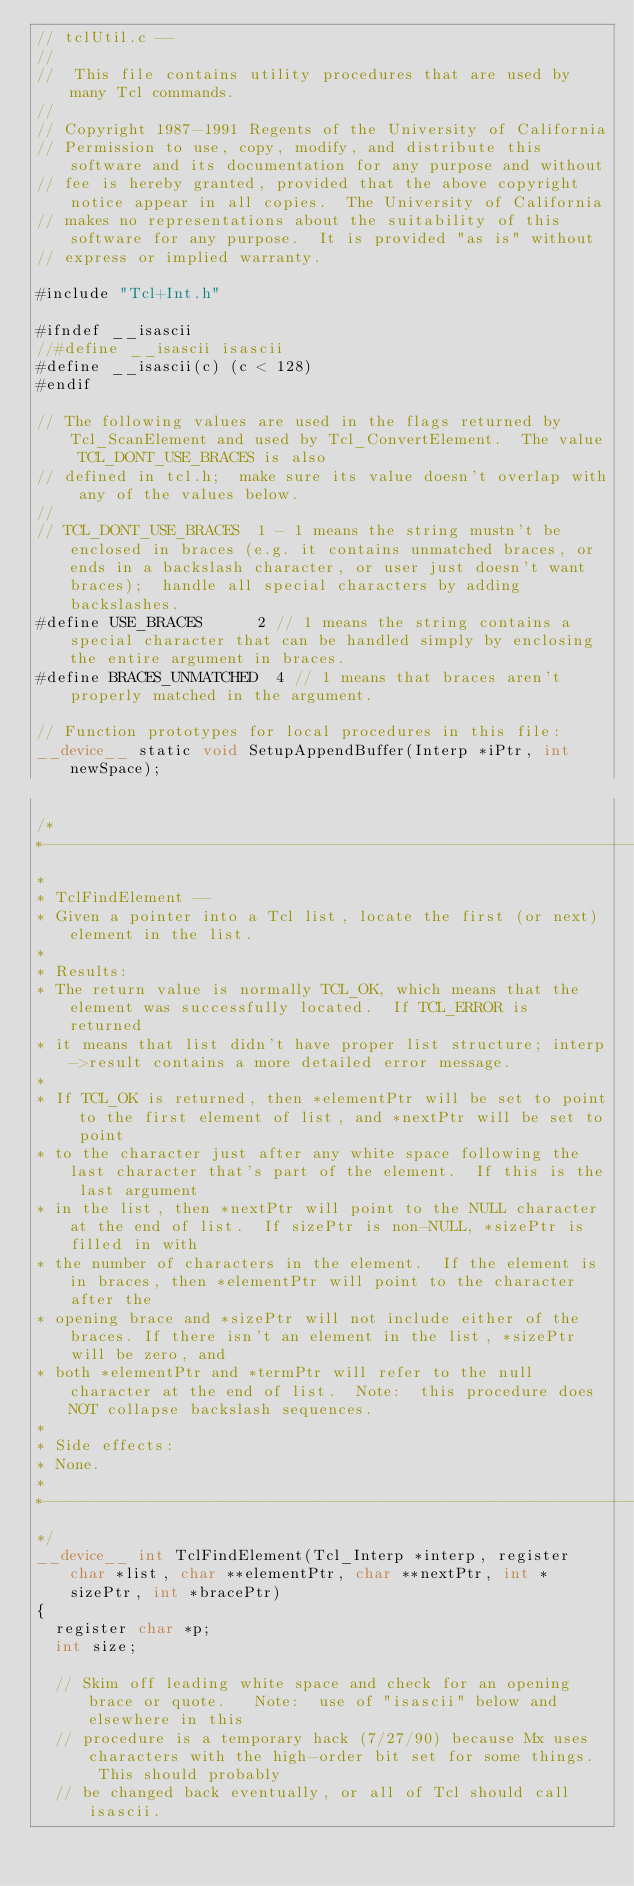<code> <loc_0><loc_0><loc_500><loc_500><_Cuda_>// tclUtil.c --
//
//	This file contains utility procedures that are used by many Tcl commands.
//
// Copyright 1987-1991 Regents of the University of California
// Permission to use, copy, modify, and distribute this software and its documentation for any purpose and without
// fee is hereby granted, provided that the above copyright notice appear in all copies.  The University of California
// makes no representations about the suitability of this software for any purpose.  It is provided "as is" without
// express or implied warranty.

#include "Tcl+Int.h"

#ifndef __isascii
//#define __isascii isascii
#define __isascii(c) (c < 128)
#endif

// The following values are used in the flags returned by Tcl_ScanElement and used by Tcl_ConvertElement.  The value TCL_DONT_USE_BRACES is also
// defined in tcl.h;  make sure its value doesn't overlap with any of the values below.
//
// TCL_DONT_USE_BRACES  1 - 1 means the string mustn't be enclosed in braces (e.g. it contains unmatched braces, or ends in a backslash character, or user just doesn't want braces);  handle all special characters by adding backslashes.
#define USE_BRACES			2 // 1 means the string contains a special character that can be handled simply by enclosing the entire argument in braces.
#define BRACES_UNMATCHED	4 // 1 means that braces aren't properly matched in the argument. 

// Function prototypes for local procedures in this file:
__device__ static void SetupAppendBuffer(Interp *iPtr, int newSpace);

/*
*----------------------------------------------------------------------
*
* TclFindElement --
*	Given a pointer into a Tcl list, locate the first (or next) element in the list.
*
* Results:
*	The return value is normally TCL_OK, which means that the element was successfully located.  If TCL_ERROR is returned
*	it means that list didn't have proper list structure; interp->result contains a more detailed error message.
*
*	If TCL_OK is returned, then *elementPtr will be set to point to the first element of list, and *nextPtr will be set to point
*	to the character just after any white space following the last character that's part of the element.  If this is the last argument
*	in the list, then *nextPtr will point to the NULL character at the end of list.  If sizePtr is non-NULL, *sizePtr is filled in with
*	the number of characters in the element.  If the element is in braces, then *elementPtr will point to the character after the
*	opening brace and *sizePtr will not include either of the braces. If there isn't an element in the list, *sizePtr will be zero, and
*	both *elementPtr and *termPtr will refer to the null character at the end of list.  Note:  this procedure does NOT collapse backslash sequences.
*
* Side effects:
*	None.
*
*----------------------------------------------------------------------
*/
__device__ int TclFindElement(Tcl_Interp *interp, register char *list, char **elementPtr, char **nextPtr, int *sizePtr, int *bracePtr)
{
	register char *p;
	int size;

	// Skim off leading white space and check for an opening brace or quote.   Note:  use of "isascii" below and elsewhere in this
	// procedure is a temporary hack (7/27/90) because Mx uses characters with the high-order bit set for some things.  This should probably
	// be changed back eventually, or all of Tcl should call isascii.</code> 